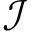Convert formula to latex. <formula><loc_0><loc_0><loc_500><loc_500>{ \mathcal { I } }</formula> 